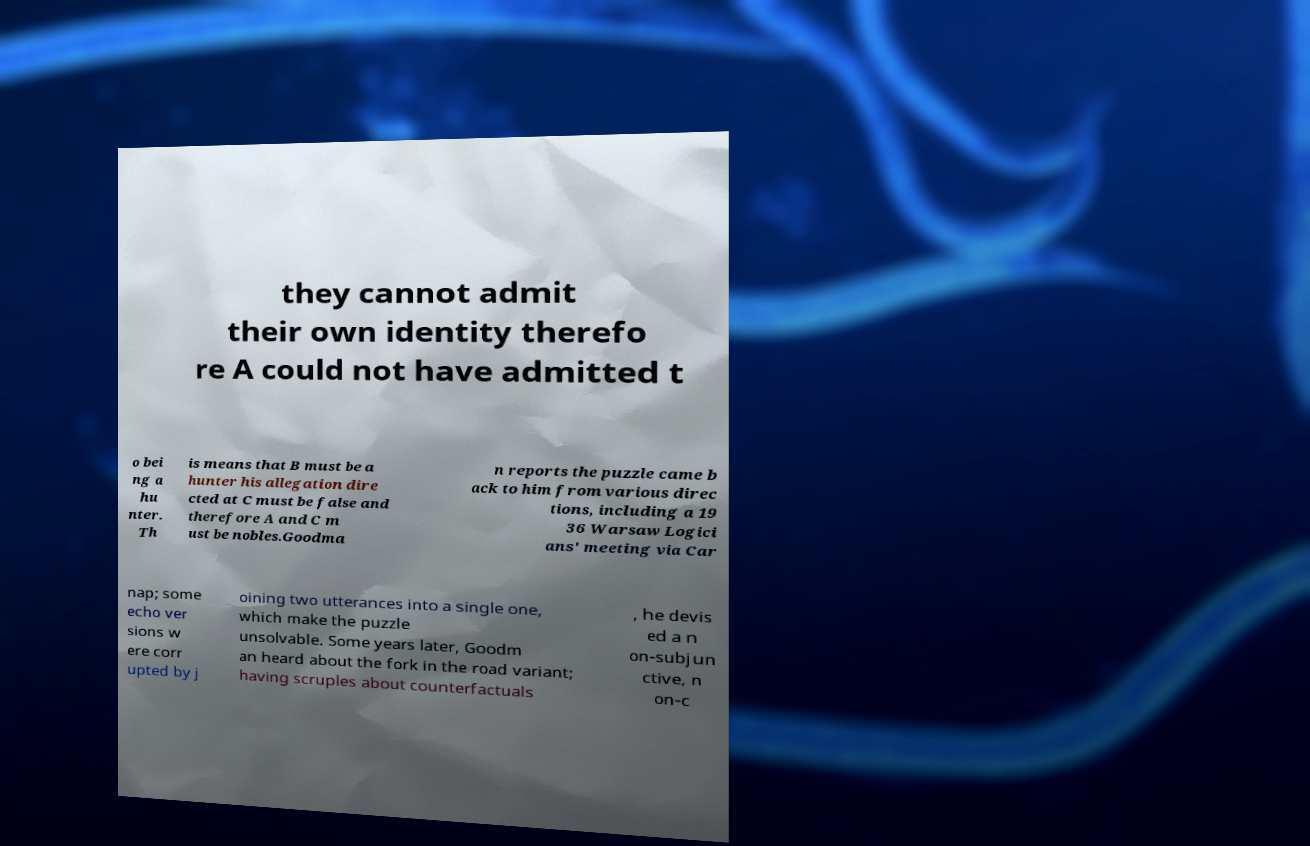Could you extract and type out the text from this image? they cannot admit their own identity therefo re A could not have admitted t o bei ng a hu nter. Th is means that B must be a hunter his allegation dire cted at C must be false and therefore A and C m ust be nobles.Goodma n reports the puzzle came b ack to him from various direc tions, including a 19 36 Warsaw Logici ans' meeting via Car nap; some echo ver sions w ere corr upted by j oining two utterances into a single one, which make the puzzle unsolvable. Some years later, Goodm an heard about the fork in the road variant; having scruples about counterfactuals , he devis ed a n on-subjun ctive, n on-c 